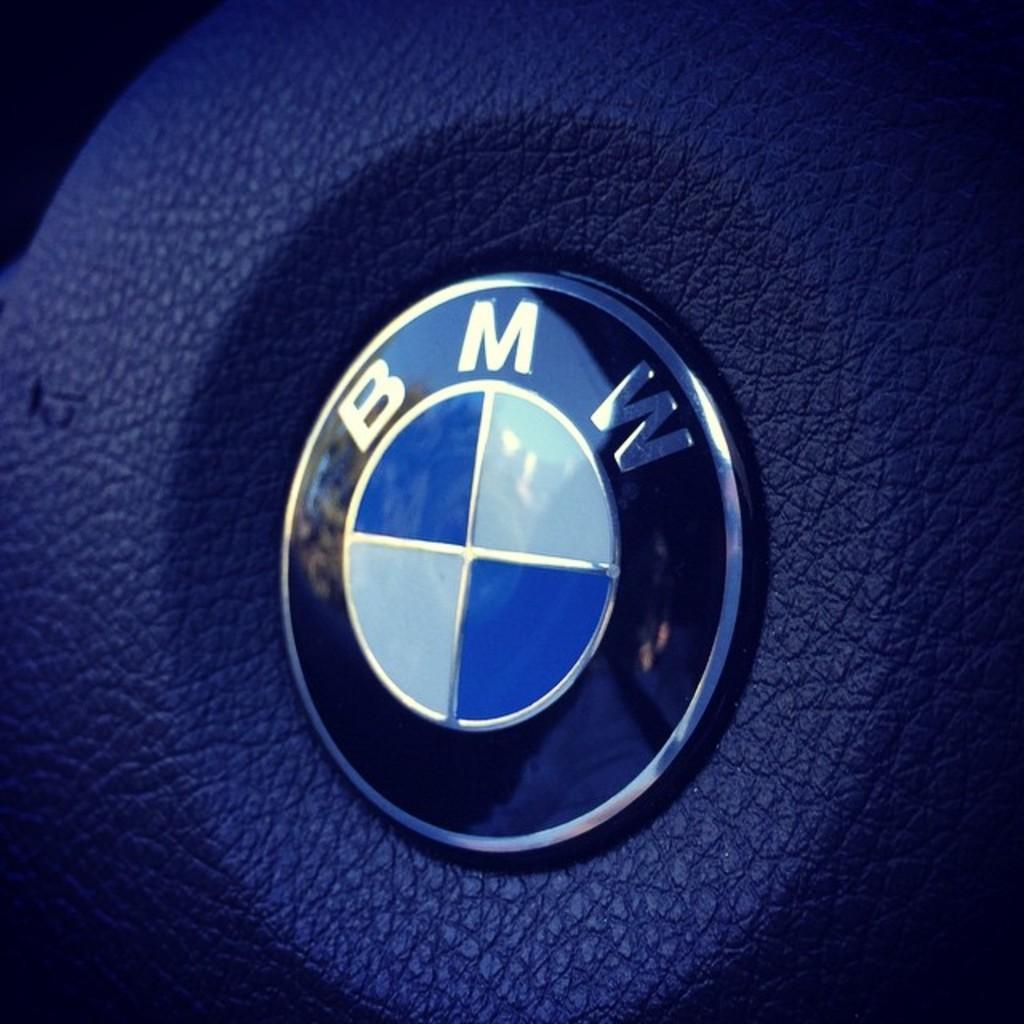Describe this image in one or two sentences. In this image I can see the logo and I can see the blue color background. 